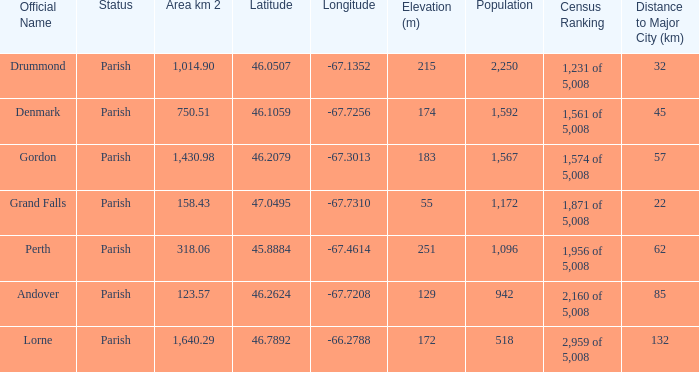Which parish has an area of 750.51? Denmark. 